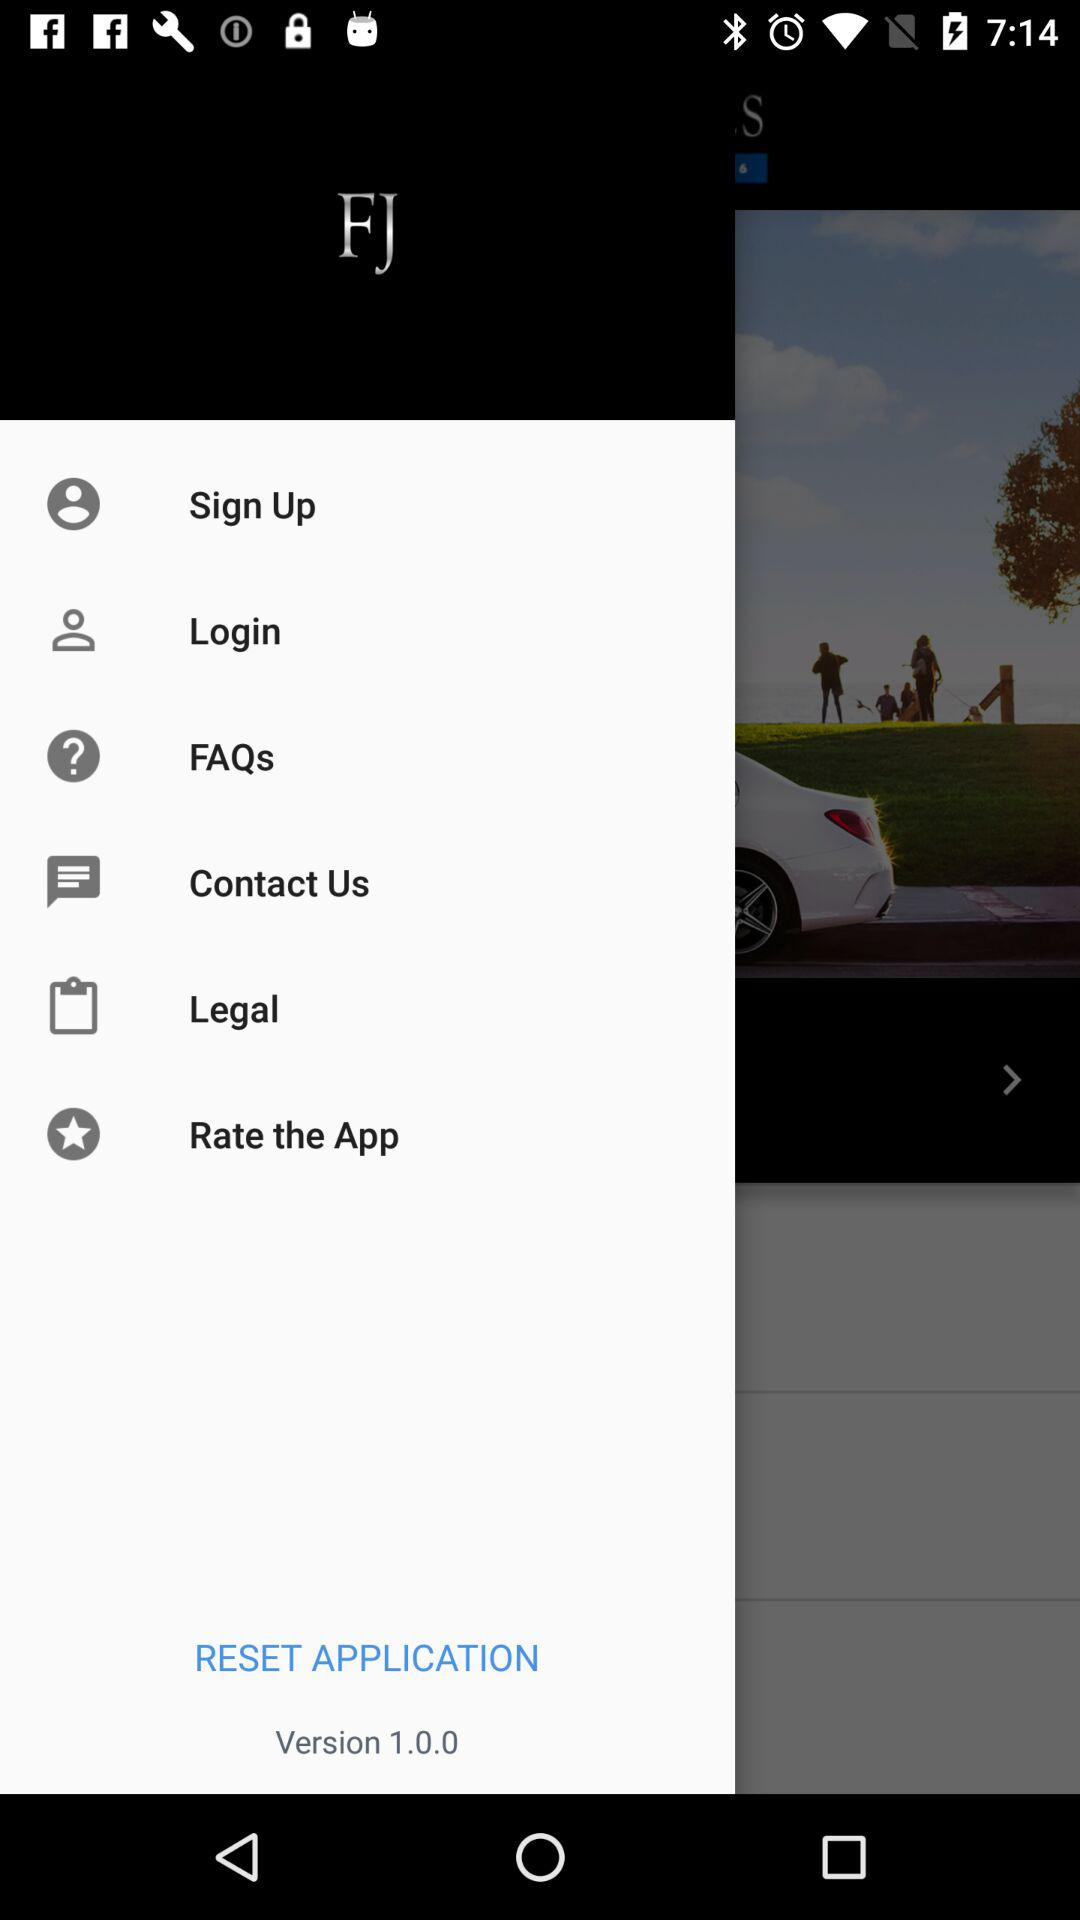What is the application name? The application name is "FJ". 